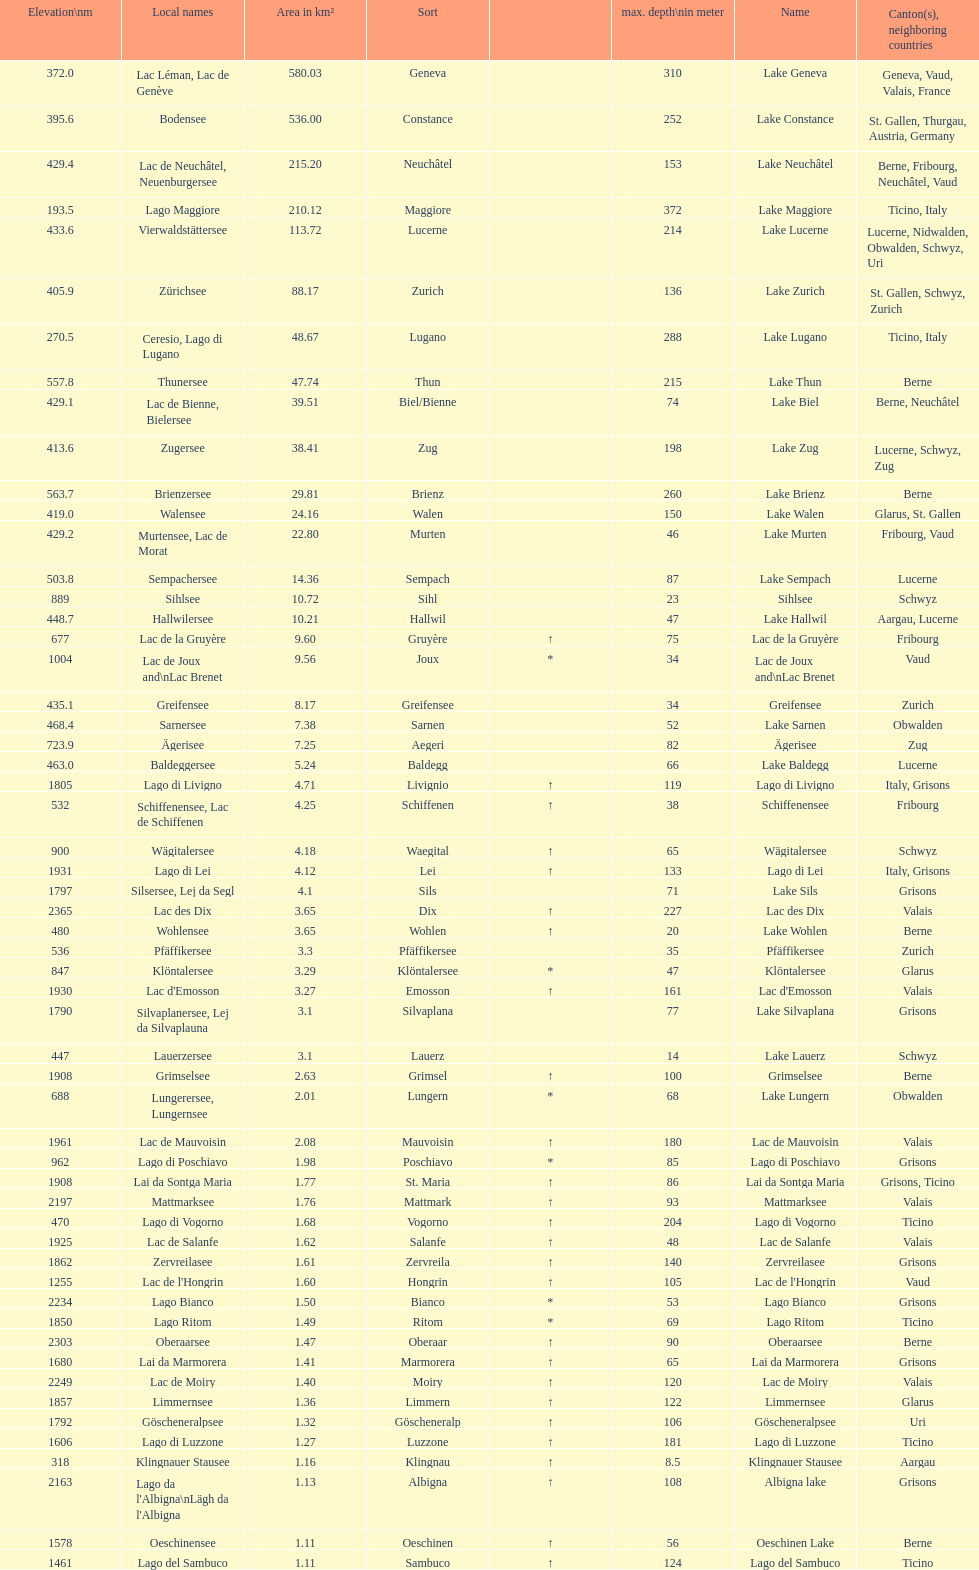Which lake can be found at an elevation exceeding 193m? Lake Maggiore. 